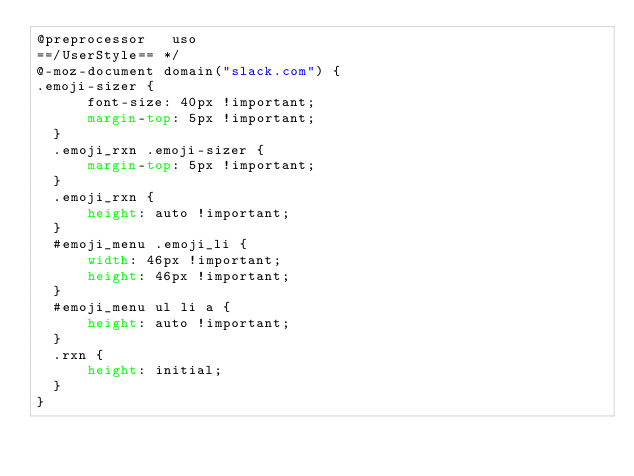<code> <loc_0><loc_0><loc_500><loc_500><_CSS_>@preprocessor   uso
==/UserStyle== */
@-moz-document domain("slack.com") {
.emoji-sizer {
      font-size: 40px !important;
      margin-top: 5px !important;
  }
  .emoji_rxn .emoji-sizer {
      margin-top: 5px !important;
  }
  .emoji_rxn {
      height: auto !important;
  }
  #emoji_menu .emoji_li {
      width: 46px !important;
      height: 46px !important;
  }
  #emoji_menu ul li a {
      height: auto !important;
  }
  .rxn {
      height: initial;
  }
}</code> 